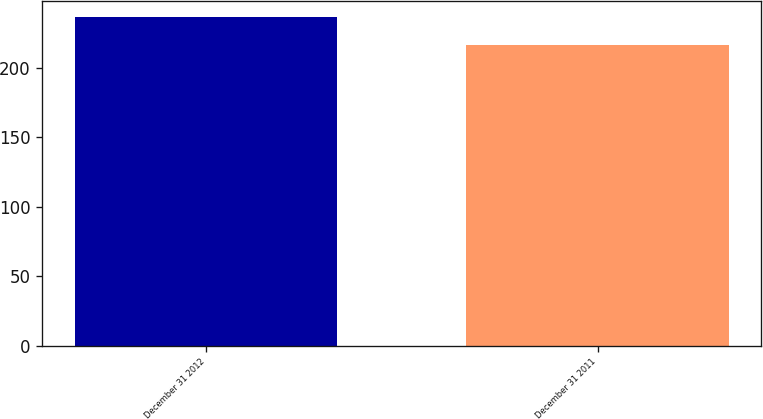Convert chart. <chart><loc_0><loc_0><loc_500><loc_500><bar_chart><fcel>December 31 2012<fcel>December 31 2011<nl><fcel>236<fcel>216.3<nl></chart> 